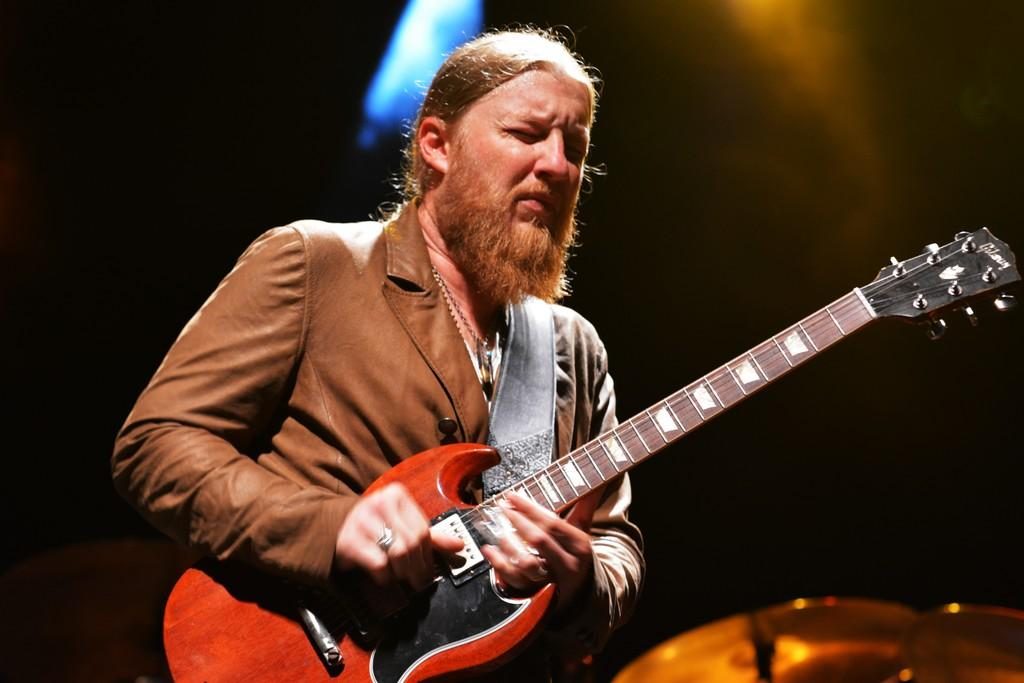Who is the main subject in the image? There is a man in the image. What is the man doing in the image? The man is playing a guitar. What event is the image from? The image is from a musical concert. What is the color of the background in the image? The background of the image is black in color. Where is the picture of the hands on the shelf in the image? There is no picture of hands on a shelf present in the image. 